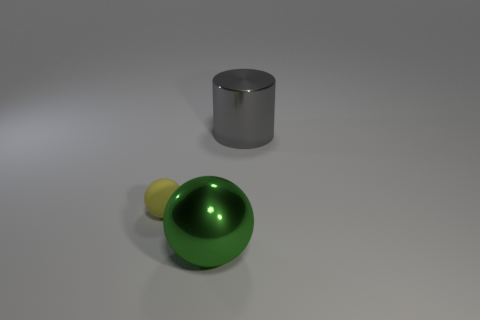Add 2 large gray cylinders. How many objects exist? 5 Subtract all cylinders. How many objects are left? 2 Subtract 0 red cylinders. How many objects are left? 3 Subtract all blue metal cubes. Subtract all large metallic cylinders. How many objects are left? 2 Add 3 large gray shiny cylinders. How many large gray shiny cylinders are left? 4 Add 3 green balls. How many green balls exist? 4 